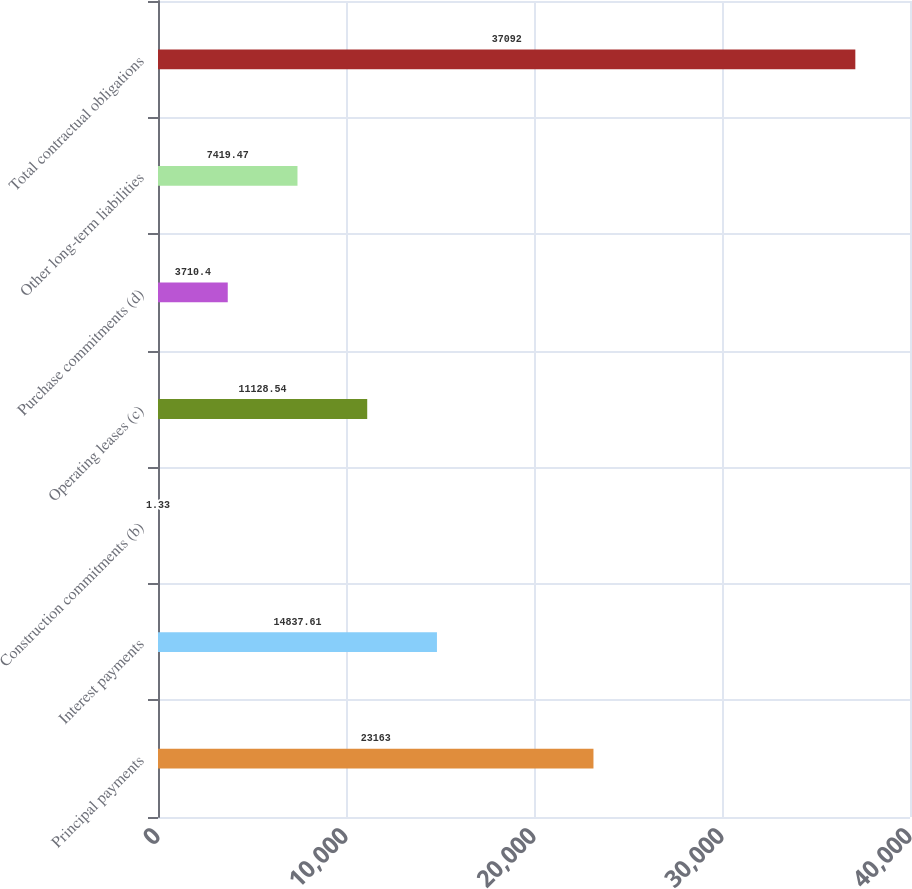<chart> <loc_0><loc_0><loc_500><loc_500><bar_chart><fcel>Principal payments<fcel>Interest payments<fcel>Construction commitments (b)<fcel>Operating leases (c)<fcel>Purchase commitments (d)<fcel>Other long-term liabilities<fcel>Total contractual obligations<nl><fcel>23163<fcel>14837.6<fcel>1.33<fcel>11128.5<fcel>3710.4<fcel>7419.47<fcel>37092<nl></chart> 